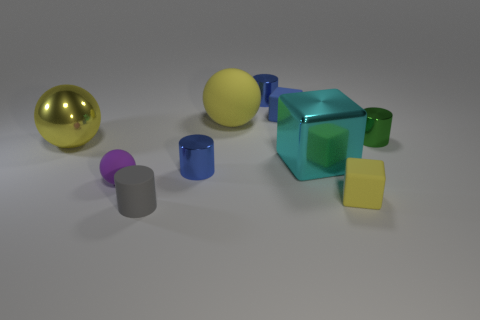What number of rubber blocks are in front of the big matte object?
Ensure brevity in your answer.  1. There is a cylinder behind the big sphere behind the green cylinder; how big is it?
Offer a terse response. Small. There is a small metallic object that is in front of the green metal cylinder; does it have the same shape as the small rubber thing that is behind the yellow metallic object?
Provide a short and direct response. No. There is a yellow rubber thing that is in front of the small blue metal cylinder in front of the large cyan shiny block; what shape is it?
Provide a succinct answer. Cube. There is a yellow object that is to the right of the matte cylinder and behind the purple matte sphere; how big is it?
Make the answer very short. Large. There is a tiny purple rubber object; is its shape the same as the big metal object to the left of the tiny gray matte cylinder?
Provide a short and direct response. Yes. What is the size of the other purple thing that is the same shape as the large matte object?
Offer a terse response. Small. There is a large metal cube; is its color the same as the rubber ball that is behind the green thing?
Ensure brevity in your answer.  No. How many other objects are there of the same size as the gray matte object?
Give a very brief answer. 6. The big metal object on the right side of the tiny blue object that is right of the metal thing that is behind the big yellow matte object is what shape?
Your answer should be very brief. Cube. 